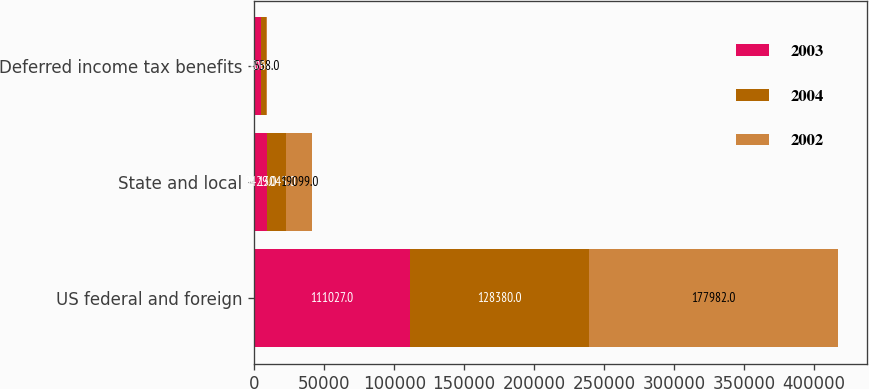<chart> <loc_0><loc_0><loc_500><loc_500><stacked_bar_chart><ecel><fcel>US federal and foreign<fcel>State and local<fcel>Deferred income tax benefits<nl><fcel>2003<fcel>111027<fcel>9429<fcel>5106<nl><fcel>2004<fcel>128380<fcel>13045<fcel>3396<nl><fcel>2002<fcel>177982<fcel>19099<fcel>558<nl></chart> 